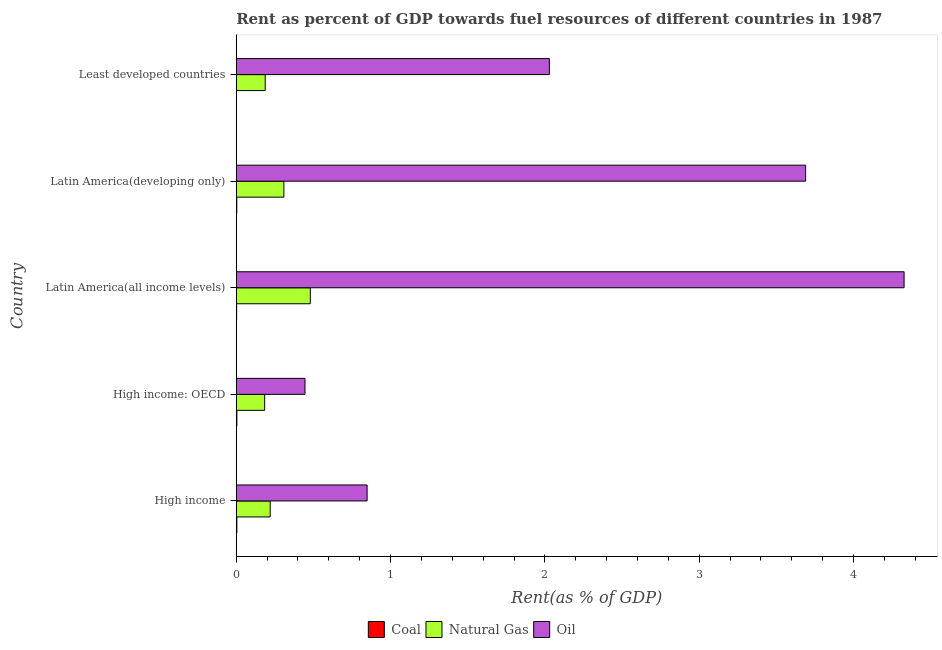How many different coloured bars are there?
Offer a very short reply. 3. How many groups of bars are there?
Provide a succinct answer. 5. How many bars are there on the 1st tick from the bottom?
Provide a short and direct response. 3. What is the label of the 3rd group of bars from the top?
Make the answer very short. Latin America(all income levels). In how many cases, is the number of bars for a given country not equal to the number of legend labels?
Ensure brevity in your answer.  0. What is the rent towards oil in High income: OECD?
Keep it short and to the point. 0.45. Across all countries, what is the maximum rent towards coal?
Provide a short and direct response. 0. Across all countries, what is the minimum rent towards natural gas?
Ensure brevity in your answer.  0.18. In which country was the rent towards natural gas maximum?
Keep it short and to the point. Latin America(all income levels). In which country was the rent towards coal minimum?
Provide a short and direct response. Least developed countries. What is the total rent towards natural gas in the graph?
Provide a succinct answer. 1.38. What is the difference between the rent towards natural gas in High income and that in High income: OECD?
Offer a terse response. 0.04. What is the difference between the rent towards natural gas in Least developed countries and the rent towards oil in Latin America(all income levels)?
Provide a succinct answer. -4.14. What is the average rent towards oil per country?
Your answer should be very brief. 2.27. What is the difference between the rent towards natural gas and rent towards oil in Latin America(all income levels)?
Provide a succinct answer. -3.85. What is the ratio of the rent towards oil in Latin America(all income levels) to that in Latin America(developing only)?
Ensure brevity in your answer.  1.17. What is the difference between the highest and the second highest rent towards oil?
Give a very brief answer. 0.64. In how many countries, is the rent towards oil greater than the average rent towards oil taken over all countries?
Keep it short and to the point. 2. Is the sum of the rent towards coal in Latin America(all income levels) and Least developed countries greater than the maximum rent towards natural gas across all countries?
Ensure brevity in your answer.  No. What does the 3rd bar from the top in Latin America(developing only) represents?
Provide a short and direct response. Coal. What does the 2nd bar from the bottom in High income represents?
Offer a terse response. Natural Gas. Is it the case that in every country, the sum of the rent towards coal and rent towards natural gas is greater than the rent towards oil?
Your answer should be very brief. No. Are all the bars in the graph horizontal?
Ensure brevity in your answer.  Yes. Are the values on the major ticks of X-axis written in scientific E-notation?
Give a very brief answer. No. Does the graph contain any zero values?
Your answer should be very brief. No. Does the graph contain grids?
Your answer should be compact. No. Where does the legend appear in the graph?
Your response must be concise. Bottom center. How many legend labels are there?
Your response must be concise. 3. How are the legend labels stacked?
Your answer should be very brief. Horizontal. What is the title of the graph?
Your answer should be very brief. Rent as percent of GDP towards fuel resources of different countries in 1987. Does "Ages 60+" appear as one of the legend labels in the graph?
Make the answer very short. No. What is the label or title of the X-axis?
Provide a short and direct response. Rent(as % of GDP). What is the label or title of the Y-axis?
Your answer should be compact. Country. What is the Rent(as % of GDP) in Coal in High income?
Make the answer very short. 0. What is the Rent(as % of GDP) in Natural Gas in High income?
Offer a very short reply. 0.22. What is the Rent(as % of GDP) of Oil in High income?
Provide a succinct answer. 0.85. What is the Rent(as % of GDP) of Coal in High income: OECD?
Keep it short and to the point. 0. What is the Rent(as % of GDP) in Natural Gas in High income: OECD?
Ensure brevity in your answer.  0.18. What is the Rent(as % of GDP) in Oil in High income: OECD?
Ensure brevity in your answer.  0.45. What is the Rent(as % of GDP) of Coal in Latin America(all income levels)?
Make the answer very short. 0. What is the Rent(as % of GDP) of Natural Gas in Latin America(all income levels)?
Provide a succinct answer. 0.48. What is the Rent(as % of GDP) in Oil in Latin America(all income levels)?
Your answer should be very brief. 4.33. What is the Rent(as % of GDP) in Coal in Latin America(developing only)?
Give a very brief answer. 0. What is the Rent(as % of GDP) in Natural Gas in Latin America(developing only)?
Give a very brief answer. 0.31. What is the Rent(as % of GDP) of Oil in Latin America(developing only)?
Provide a short and direct response. 3.69. What is the Rent(as % of GDP) in Coal in Least developed countries?
Give a very brief answer. 5.84697420507121e-6. What is the Rent(as % of GDP) in Natural Gas in Least developed countries?
Your answer should be very brief. 0.19. What is the Rent(as % of GDP) in Oil in Least developed countries?
Make the answer very short. 2.03. Across all countries, what is the maximum Rent(as % of GDP) of Coal?
Make the answer very short. 0. Across all countries, what is the maximum Rent(as % of GDP) in Natural Gas?
Give a very brief answer. 0.48. Across all countries, what is the maximum Rent(as % of GDP) in Oil?
Your answer should be very brief. 4.33. Across all countries, what is the minimum Rent(as % of GDP) in Coal?
Offer a very short reply. 5.84697420507121e-6. Across all countries, what is the minimum Rent(as % of GDP) of Natural Gas?
Ensure brevity in your answer.  0.18. Across all countries, what is the minimum Rent(as % of GDP) in Oil?
Your answer should be compact. 0.45. What is the total Rent(as % of GDP) of Coal in the graph?
Provide a succinct answer. 0.01. What is the total Rent(as % of GDP) in Natural Gas in the graph?
Make the answer very short. 1.38. What is the total Rent(as % of GDP) of Oil in the graph?
Offer a terse response. 11.34. What is the difference between the Rent(as % of GDP) in Coal in High income and that in High income: OECD?
Offer a very short reply. -0. What is the difference between the Rent(as % of GDP) of Natural Gas in High income and that in High income: OECD?
Offer a very short reply. 0.04. What is the difference between the Rent(as % of GDP) in Oil in High income and that in High income: OECD?
Keep it short and to the point. 0.4. What is the difference between the Rent(as % of GDP) of Coal in High income and that in Latin America(all income levels)?
Your answer should be very brief. 0. What is the difference between the Rent(as % of GDP) of Natural Gas in High income and that in Latin America(all income levels)?
Give a very brief answer. -0.26. What is the difference between the Rent(as % of GDP) of Oil in High income and that in Latin America(all income levels)?
Provide a succinct answer. -3.48. What is the difference between the Rent(as % of GDP) of Coal in High income and that in Latin America(developing only)?
Provide a succinct answer. 0. What is the difference between the Rent(as % of GDP) of Natural Gas in High income and that in Latin America(developing only)?
Offer a terse response. -0.09. What is the difference between the Rent(as % of GDP) of Oil in High income and that in Latin America(developing only)?
Offer a terse response. -2.84. What is the difference between the Rent(as % of GDP) of Coal in High income and that in Least developed countries?
Provide a succinct answer. 0. What is the difference between the Rent(as % of GDP) of Natural Gas in High income and that in Least developed countries?
Offer a terse response. 0.03. What is the difference between the Rent(as % of GDP) in Oil in High income and that in Least developed countries?
Keep it short and to the point. -1.18. What is the difference between the Rent(as % of GDP) of Coal in High income: OECD and that in Latin America(all income levels)?
Provide a succinct answer. 0. What is the difference between the Rent(as % of GDP) in Natural Gas in High income: OECD and that in Latin America(all income levels)?
Your answer should be compact. -0.3. What is the difference between the Rent(as % of GDP) of Oil in High income: OECD and that in Latin America(all income levels)?
Ensure brevity in your answer.  -3.88. What is the difference between the Rent(as % of GDP) of Coal in High income: OECD and that in Latin America(developing only)?
Make the answer very short. 0. What is the difference between the Rent(as % of GDP) of Natural Gas in High income: OECD and that in Latin America(developing only)?
Offer a very short reply. -0.12. What is the difference between the Rent(as % of GDP) of Oil in High income: OECD and that in Latin America(developing only)?
Provide a succinct answer. -3.24. What is the difference between the Rent(as % of GDP) of Coal in High income: OECD and that in Least developed countries?
Make the answer very short. 0. What is the difference between the Rent(as % of GDP) of Natural Gas in High income: OECD and that in Least developed countries?
Offer a very short reply. -0. What is the difference between the Rent(as % of GDP) in Oil in High income: OECD and that in Least developed countries?
Ensure brevity in your answer.  -1.58. What is the difference between the Rent(as % of GDP) of Coal in Latin America(all income levels) and that in Latin America(developing only)?
Keep it short and to the point. -0. What is the difference between the Rent(as % of GDP) in Natural Gas in Latin America(all income levels) and that in Latin America(developing only)?
Provide a succinct answer. 0.17. What is the difference between the Rent(as % of GDP) in Oil in Latin America(all income levels) and that in Latin America(developing only)?
Your answer should be very brief. 0.64. What is the difference between the Rent(as % of GDP) of Coal in Latin America(all income levels) and that in Least developed countries?
Offer a terse response. 0. What is the difference between the Rent(as % of GDP) of Natural Gas in Latin America(all income levels) and that in Least developed countries?
Provide a succinct answer. 0.29. What is the difference between the Rent(as % of GDP) of Oil in Latin America(all income levels) and that in Least developed countries?
Offer a very short reply. 2.3. What is the difference between the Rent(as % of GDP) of Coal in Latin America(developing only) and that in Least developed countries?
Your answer should be compact. 0. What is the difference between the Rent(as % of GDP) in Natural Gas in Latin America(developing only) and that in Least developed countries?
Give a very brief answer. 0.12. What is the difference between the Rent(as % of GDP) in Oil in Latin America(developing only) and that in Least developed countries?
Provide a succinct answer. 1.66. What is the difference between the Rent(as % of GDP) of Coal in High income and the Rent(as % of GDP) of Natural Gas in High income: OECD?
Give a very brief answer. -0.18. What is the difference between the Rent(as % of GDP) in Coal in High income and the Rent(as % of GDP) in Oil in High income: OECD?
Keep it short and to the point. -0.44. What is the difference between the Rent(as % of GDP) in Natural Gas in High income and the Rent(as % of GDP) in Oil in High income: OECD?
Offer a very short reply. -0.23. What is the difference between the Rent(as % of GDP) of Coal in High income and the Rent(as % of GDP) of Natural Gas in Latin America(all income levels)?
Make the answer very short. -0.48. What is the difference between the Rent(as % of GDP) in Coal in High income and the Rent(as % of GDP) in Oil in Latin America(all income levels)?
Keep it short and to the point. -4.32. What is the difference between the Rent(as % of GDP) of Natural Gas in High income and the Rent(as % of GDP) of Oil in Latin America(all income levels)?
Your answer should be compact. -4.11. What is the difference between the Rent(as % of GDP) in Coal in High income and the Rent(as % of GDP) in Natural Gas in Latin America(developing only)?
Ensure brevity in your answer.  -0.3. What is the difference between the Rent(as % of GDP) of Coal in High income and the Rent(as % of GDP) of Oil in Latin America(developing only)?
Ensure brevity in your answer.  -3.69. What is the difference between the Rent(as % of GDP) of Natural Gas in High income and the Rent(as % of GDP) of Oil in Latin America(developing only)?
Ensure brevity in your answer.  -3.47. What is the difference between the Rent(as % of GDP) of Coal in High income and the Rent(as % of GDP) of Natural Gas in Least developed countries?
Provide a short and direct response. -0.18. What is the difference between the Rent(as % of GDP) in Coal in High income and the Rent(as % of GDP) in Oil in Least developed countries?
Offer a terse response. -2.03. What is the difference between the Rent(as % of GDP) in Natural Gas in High income and the Rent(as % of GDP) in Oil in Least developed countries?
Keep it short and to the point. -1.81. What is the difference between the Rent(as % of GDP) in Coal in High income: OECD and the Rent(as % of GDP) in Natural Gas in Latin America(all income levels)?
Ensure brevity in your answer.  -0.48. What is the difference between the Rent(as % of GDP) of Coal in High income: OECD and the Rent(as % of GDP) of Oil in Latin America(all income levels)?
Offer a very short reply. -4.32. What is the difference between the Rent(as % of GDP) of Natural Gas in High income: OECD and the Rent(as % of GDP) of Oil in Latin America(all income levels)?
Your answer should be very brief. -4.14. What is the difference between the Rent(as % of GDP) of Coal in High income: OECD and the Rent(as % of GDP) of Natural Gas in Latin America(developing only)?
Offer a very short reply. -0.3. What is the difference between the Rent(as % of GDP) of Coal in High income: OECD and the Rent(as % of GDP) of Oil in Latin America(developing only)?
Provide a succinct answer. -3.69. What is the difference between the Rent(as % of GDP) of Natural Gas in High income: OECD and the Rent(as % of GDP) of Oil in Latin America(developing only)?
Your answer should be compact. -3.51. What is the difference between the Rent(as % of GDP) of Coal in High income: OECD and the Rent(as % of GDP) of Natural Gas in Least developed countries?
Offer a terse response. -0.18. What is the difference between the Rent(as % of GDP) in Coal in High income: OECD and the Rent(as % of GDP) in Oil in Least developed countries?
Your answer should be very brief. -2.02. What is the difference between the Rent(as % of GDP) in Natural Gas in High income: OECD and the Rent(as % of GDP) in Oil in Least developed countries?
Your response must be concise. -1.84. What is the difference between the Rent(as % of GDP) of Coal in Latin America(all income levels) and the Rent(as % of GDP) of Natural Gas in Latin America(developing only)?
Give a very brief answer. -0.31. What is the difference between the Rent(as % of GDP) in Coal in Latin America(all income levels) and the Rent(as % of GDP) in Oil in Latin America(developing only)?
Make the answer very short. -3.69. What is the difference between the Rent(as % of GDP) in Natural Gas in Latin America(all income levels) and the Rent(as % of GDP) in Oil in Latin America(developing only)?
Make the answer very short. -3.21. What is the difference between the Rent(as % of GDP) in Coal in Latin America(all income levels) and the Rent(as % of GDP) in Natural Gas in Least developed countries?
Your response must be concise. -0.19. What is the difference between the Rent(as % of GDP) of Coal in Latin America(all income levels) and the Rent(as % of GDP) of Oil in Least developed countries?
Your answer should be compact. -2.03. What is the difference between the Rent(as % of GDP) of Natural Gas in Latin America(all income levels) and the Rent(as % of GDP) of Oil in Least developed countries?
Offer a terse response. -1.55. What is the difference between the Rent(as % of GDP) of Coal in Latin America(developing only) and the Rent(as % of GDP) of Natural Gas in Least developed countries?
Offer a terse response. -0.18. What is the difference between the Rent(as % of GDP) in Coal in Latin America(developing only) and the Rent(as % of GDP) in Oil in Least developed countries?
Your answer should be compact. -2.03. What is the difference between the Rent(as % of GDP) in Natural Gas in Latin America(developing only) and the Rent(as % of GDP) in Oil in Least developed countries?
Ensure brevity in your answer.  -1.72. What is the average Rent(as % of GDP) in Coal per country?
Give a very brief answer. 0. What is the average Rent(as % of GDP) of Natural Gas per country?
Offer a very short reply. 0.28. What is the average Rent(as % of GDP) of Oil per country?
Your response must be concise. 2.27. What is the difference between the Rent(as % of GDP) in Coal and Rent(as % of GDP) in Natural Gas in High income?
Offer a very short reply. -0.22. What is the difference between the Rent(as % of GDP) in Coal and Rent(as % of GDP) in Oil in High income?
Offer a very short reply. -0.84. What is the difference between the Rent(as % of GDP) in Natural Gas and Rent(as % of GDP) in Oil in High income?
Offer a terse response. -0.63. What is the difference between the Rent(as % of GDP) of Coal and Rent(as % of GDP) of Natural Gas in High income: OECD?
Offer a very short reply. -0.18. What is the difference between the Rent(as % of GDP) in Coal and Rent(as % of GDP) in Oil in High income: OECD?
Ensure brevity in your answer.  -0.44. What is the difference between the Rent(as % of GDP) of Natural Gas and Rent(as % of GDP) of Oil in High income: OECD?
Provide a succinct answer. -0.26. What is the difference between the Rent(as % of GDP) in Coal and Rent(as % of GDP) in Natural Gas in Latin America(all income levels)?
Offer a terse response. -0.48. What is the difference between the Rent(as % of GDP) of Coal and Rent(as % of GDP) of Oil in Latin America(all income levels)?
Offer a very short reply. -4.33. What is the difference between the Rent(as % of GDP) of Natural Gas and Rent(as % of GDP) of Oil in Latin America(all income levels)?
Your response must be concise. -3.85. What is the difference between the Rent(as % of GDP) of Coal and Rent(as % of GDP) of Natural Gas in Latin America(developing only)?
Give a very brief answer. -0.31. What is the difference between the Rent(as % of GDP) in Coal and Rent(as % of GDP) in Oil in Latin America(developing only)?
Keep it short and to the point. -3.69. What is the difference between the Rent(as % of GDP) in Natural Gas and Rent(as % of GDP) in Oil in Latin America(developing only)?
Offer a terse response. -3.38. What is the difference between the Rent(as % of GDP) of Coal and Rent(as % of GDP) of Natural Gas in Least developed countries?
Your answer should be very brief. -0.19. What is the difference between the Rent(as % of GDP) in Coal and Rent(as % of GDP) in Oil in Least developed countries?
Ensure brevity in your answer.  -2.03. What is the difference between the Rent(as % of GDP) of Natural Gas and Rent(as % of GDP) of Oil in Least developed countries?
Keep it short and to the point. -1.84. What is the ratio of the Rent(as % of GDP) of Coal in High income to that in High income: OECD?
Offer a very short reply. 0.96. What is the ratio of the Rent(as % of GDP) in Natural Gas in High income to that in High income: OECD?
Your answer should be very brief. 1.19. What is the ratio of the Rent(as % of GDP) of Oil in High income to that in High income: OECD?
Provide a short and direct response. 1.9. What is the ratio of the Rent(as % of GDP) in Coal in High income to that in Latin America(all income levels)?
Keep it short and to the point. 1.57. What is the ratio of the Rent(as % of GDP) in Natural Gas in High income to that in Latin America(all income levels)?
Give a very brief answer. 0.46. What is the ratio of the Rent(as % of GDP) of Oil in High income to that in Latin America(all income levels)?
Make the answer very short. 0.2. What is the ratio of the Rent(as % of GDP) of Coal in High income to that in Latin America(developing only)?
Offer a terse response. 1.14. What is the ratio of the Rent(as % of GDP) in Natural Gas in High income to that in Latin America(developing only)?
Ensure brevity in your answer.  0.71. What is the ratio of the Rent(as % of GDP) in Oil in High income to that in Latin America(developing only)?
Your response must be concise. 0.23. What is the ratio of the Rent(as % of GDP) in Coal in High income to that in Least developed countries?
Provide a succinct answer. 668.19. What is the ratio of the Rent(as % of GDP) of Natural Gas in High income to that in Least developed countries?
Your response must be concise. 1.17. What is the ratio of the Rent(as % of GDP) in Oil in High income to that in Least developed countries?
Keep it short and to the point. 0.42. What is the ratio of the Rent(as % of GDP) of Coal in High income: OECD to that in Latin America(all income levels)?
Your answer should be compact. 1.64. What is the ratio of the Rent(as % of GDP) of Natural Gas in High income: OECD to that in Latin America(all income levels)?
Your response must be concise. 0.38. What is the ratio of the Rent(as % of GDP) in Oil in High income: OECD to that in Latin America(all income levels)?
Keep it short and to the point. 0.1. What is the ratio of the Rent(as % of GDP) of Coal in High income: OECD to that in Latin America(developing only)?
Offer a very short reply. 1.19. What is the ratio of the Rent(as % of GDP) in Natural Gas in High income: OECD to that in Latin America(developing only)?
Your response must be concise. 0.6. What is the ratio of the Rent(as % of GDP) in Oil in High income: OECD to that in Latin America(developing only)?
Ensure brevity in your answer.  0.12. What is the ratio of the Rent(as % of GDP) of Coal in High income: OECD to that in Least developed countries?
Give a very brief answer. 695.39. What is the ratio of the Rent(as % of GDP) of Natural Gas in High income: OECD to that in Least developed countries?
Give a very brief answer. 0.98. What is the ratio of the Rent(as % of GDP) of Oil in High income: OECD to that in Least developed countries?
Offer a very short reply. 0.22. What is the ratio of the Rent(as % of GDP) of Coal in Latin America(all income levels) to that in Latin America(developing only)?
Make the answer very short. 0.73. What is the ratio of the Rent(as % of GDP) in Natural Gas in Latin America(all income levels) to that in Latin America(developing only)?
Make the answer very short. 1.55. What is the ratio of the Rent(as % of GDP) of Oil in Latin America(all income levels) to that in Latin America(developing only)?
Provide a short and direct response. 1.17. What is the ratio of the Rent(as % of GDP) in Coal in Latin America(all income levels) to that in Least developed countries?
Offer a terse response. 425.18. What is the ratio of the Rent(as % of GDP) of Natural Gas in Latin America(all income levels) to that in Least developed countries?
Ensure brevity in your answer.  2.56. What is the ratio of the Rent(as % of GDP) in Oil in Latin America(all income levels) to that in Least developed countries?
Ensure brevity in your answer.  2.13. What is the ratio of the Rent(as % of GDP) in Coal in Latin America(developing only) to that in Least developed countries?
Your answer should be compact. 585.97. What is the ratio of the Rent(as % of GDP) in Natural Gas in Latin America(developing only) to that in Least developed countries?
Provide a succinct answer. 1.64. What is the ratio of the Rent(as % of GDP) in Oil in Latin America(developing only) to that in Least developed countries?
Provide a succinct answer. 1.82. What is the difference between the highest and the second highest Rent(as % of GDP) in Coal?
Make the answer very short. 0. What is the difference between the highest and the second highest Rent(as % of GDP) of Natural Gas?
Provide a short and direct response. 0.17. What is the difference between the highest and the second highest Rent(as % of GDP) in Oil?
Your response must be concise. 0.64. What is the difference between the highest and the lowest Rent(as % of GDP) in Coal?
Offer a terse response. 0. What is the difference between the highest and the lowest Rent(as % of GDP) of Natural Gas?
Offer a terse response. 0.3. What is the difference between the highest and the lowest Rent(as % of GDP) of Oil?
Keep it short and to the point. 3.88. 